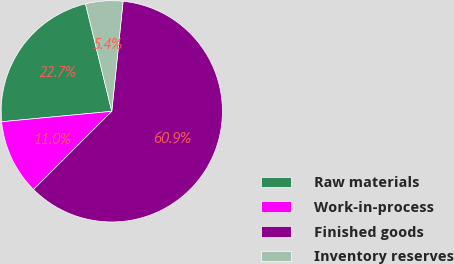Convert chart. <chart><loc_0><loc_0><loc_500><loc_500><pie_chart><fcel>Raw materials<fcel>Work-in-process<fcel>Finished goods<fcel>Inventory reserves<nl><fcel>22.69%<fcel>10.99%<fcel>60.88%<fcel>5.44%<nl></chart> 